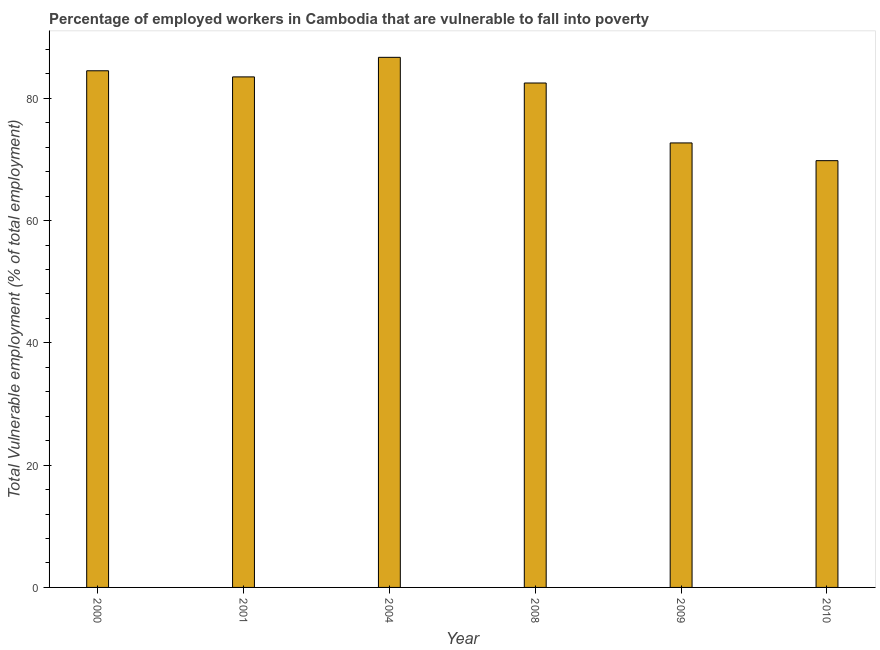Does the graph contain any zero values?
Offer a terse response. No. Does the graph contain grids?
Make the answer very short. No. What is the title of the graph?
Offer a terse response. Percentage of employed workers in Cambodia that are vulnerable to fall into poverty. What is the label or title of the Y-axis?
Ensure brevity in your answer.  Total Vulnerable employment (% of total employment). What is the total vulnerable employment in 2000?
Ensure brevity in your answer.  84.5. Across all years, what is the maximum total vulnerable employment?
Your answer should be compact. 86.7. Across all years, what is the minimum total vulnerable employment?
Your response must be concise. 69.8. In which year was the total vulnerable employment maximum?
Your answer should be compact. 2004. In which year was the total vulnerable employment minimum?
Offer a terse response. 2010. What is the sum of the total vulnerable employment?
Provide a succinct answer. 479.7. What is the difference between the total vulnerable employment in 2001 and 2008?
Your response must be concise. 1. What is the average total vulnerable employment per year?
Give a very brief answer. 79.95. What is the ratio of the total vulnerable employment in 2001 to that in 2009?
Ensure brevity in your answer.  1.15. What is the difference between the highest and the second highest total vulnerable employment?
Offer a terse response. 2.2. What is the difference between the highest and the lowest total vulnerable employment?
Your response must be concise. 16.9. How many bars are there?
Your response must be concise. 6. How many years are there in the graph?
Make the answer very short. 6. What is the difference between two consecutive major ticks on the Y-axis?
Offer a terse response. 20. What is the Total Vulnerable employment (% of total employment) in 2000?
Keep it short and to the point. 84.5. What is the Total Vulnerable employment (% of total employment) of 2001?
Your answer should be very brief. 83.5. What is the Total Vulnerable employment (% of total employment) in 2004?
Offer a terse response. 86.7. What is the Total Vulnerable employment (% of total employment) of 2008?
Keep it short and to the point. 82.5. What is the Total Vulnerable employment (% of total employment) of 2009?
Make the answer very short. 72.7. What is the Total Vulnerable employment (% of total employment) of 2010?
Offer a very short reply. 69.8. What is the difference between the Total Vulnerable employment (% of total employment) in 2000 and 2001?
Your answer should be compact. 1. What is the difference between the Total Vulnerable employment (% of total employment) in 2000 and 2004?
Your answer should be compact. -2.2. What is the difference between the Total Vulnerable employment (% of total employment) in 2000 and 2008?
Give a very brief answer. 2. What is the difference between the Total Vulnerable employment (% of total employment) in 2000 and 2009?
Your answer should be compact. 11.8. What is the difference between the Total Vulnerable employment (% of total employment) in 2000 and 2010?
Your response must be concise. 14.7. What is the difference between the Total Vulnerable employment (% of total employment) in 2001 and 2004?
Give a very brief answer. -3.2. What is the difference between the Total Vulnerable employment (% of total employment) in 2001 and 2008?
Your answer should be very brief. 1. What is the difference between the Total Vulnerable employment (% of total employment) in 2001 and 2009?
Make the answer very short. 10.8. What is the difference between the Total Vulnerable employment (% of total employment) in 2001 and 2010?
Provide a short and direct response. 13.7. What is the difference between the Total Vulnerable employment (% of total employment) in 2004 and 2009?
Provide a succinct answer. 14. What is the difference between the Total Vulnerable employment (% of total employment) in 2004 and 2010?
Offer a terse response. 16.9. What is the difference between the Total Vulnerable employment (% of total employment) in 2008 and 2009?
Offer a terse response. 9.8. What is the difference between the Total Vulnerable employment (% of total employment) in 2008 and 2010?
Provide a succinct answer. 12.7. What is the difference between the Total Vulnerable employment (% of total employment) in 2009 and 2010?
Offer a very short reply. 2.9. What is the ratio of the Total Vulnerable employment (% of total employment) in 2000 to that in 2001?
Your answer should be compact. 1.01. What is the ratio of the Total Vulnerable employment (% of total employment) in 2000 to that in 2004?
Ensure brevity in your answer.  0.97. What is the ratio of the Total Vulnerable employment (% of total employment) in 2000 to that in 2008?
Keep it short and to the point. 1.02. What is the ratio of the Total Vulnerable employment (% of total employment) in 2000 to that in 2009?
Offer a terse response. 1.16. What is the ratio of the Total Vulnerable employment (% of total employment) in 2000 to that in 2010?
Give a very brief answer. 1.21. What is the ratio of the Total Vulnerable employment (% of total employment) in 2001 to that in 2008?
Keep it short and to the point. 1.01. What is the ratio of the Total Vulnerable employment (% of total employment) in 2001 to that in 2009?
Ensure brevity in your answer.  1.15. What is the ratio of the Total Vulnerable employment (% of total employment) in 2001 to that in 2010?
Keep it short and to the point. 1.2. What is the ratio of the Total Vulnerable employment (% of total employment) in 2004 to that in 2008?
Your answer should be very brief. 1.05. What is the ratio of the Total Vulnerable employment (% of total employment) in 2004 to that in 2009?
Keep it short and to the point. 1.19. What is the ratio of the Total Vulnerable employment (% of total employment) in 2004 to that in 2010?
Offer a terse response. 1.24. What is the ratio of the Total Vulnerable employment (% of total employment) in 2008 to that in 2009?
Your response must be concise. 1.14. What is the ratio of the Total Vulnerable employment (% of total employment) in 2008 to that in 2010?
Offer a very short reply. 1.18. What is the ratio of the Total Vulnerable employment (% of total employment) in 2009 to that in 2010?
Give a very brief answer. 1.04. 